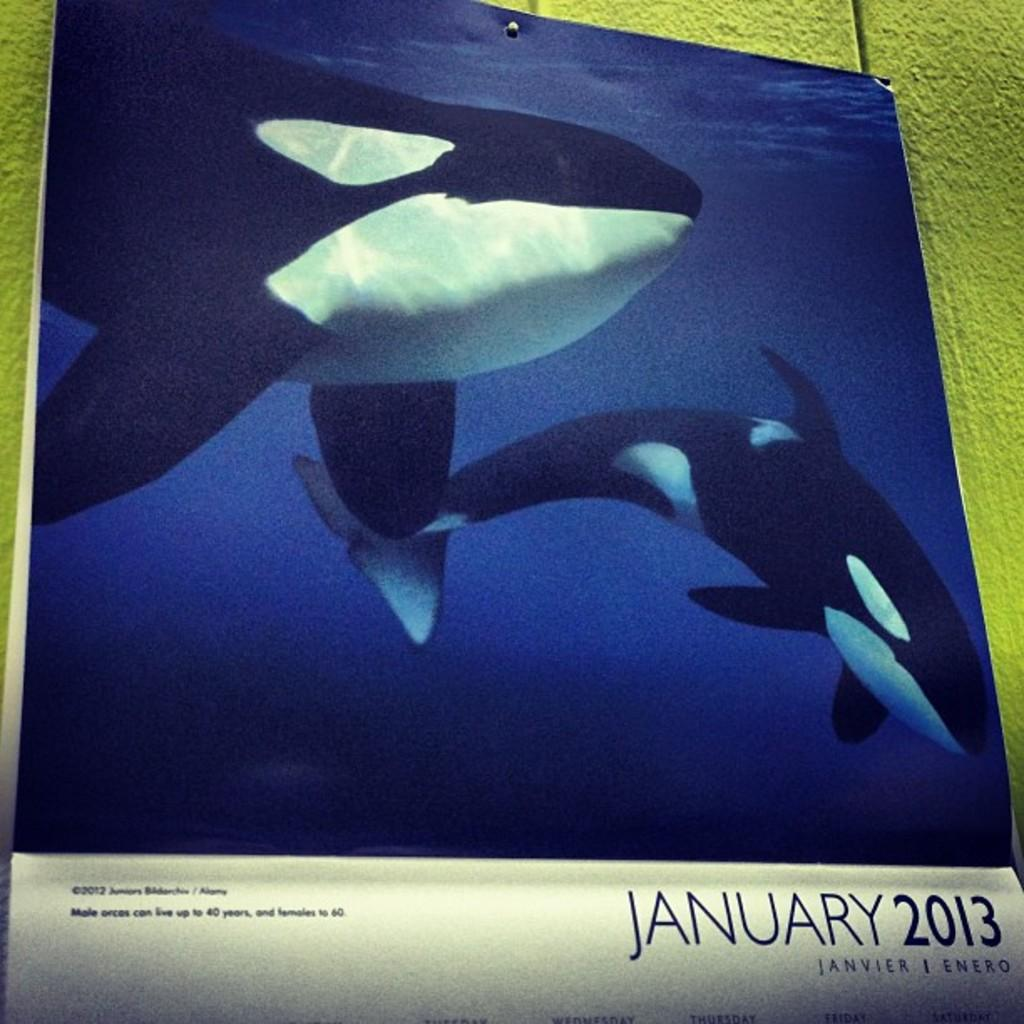What is the main object in the image? There is a calendar in the image. What is featured on the calendar? The calendar has whale images on it. How many dimes are placed on top of the calendar in the image? There is no mention of dimes in the image, so we cannot determine their presence or quantity. 